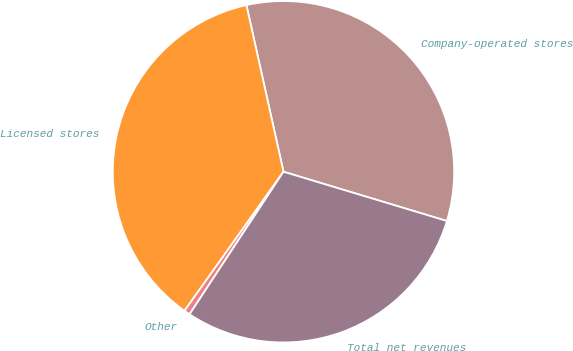Convert chart. <chart><loc_0><loc_0><loc_500><loc_500><pie_chart><fcel>Company-operated stores<fcel>Licensed stores<fcel>Other<fcel>Total net revenues<nl><fcel>33.14%<fcel>36.67%<fcel>0.57%<fcel>29.61%<nl></chart> 